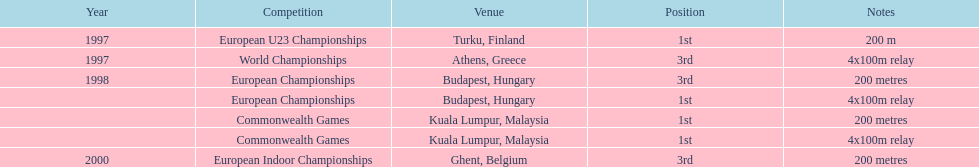How many 4x 100m relays were run? 3. 